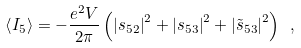<formula> <loc_0><loc_0><loc_500><loc_500>\left \langle I _ { 5 } \right \rangle = - \frac { e ^ { 2 } V } { 2 \pi } \left ( \left | s _ { 5 2 } \right | ^ { 2 } + \left | s _ { 5 3 } \right | ^ { 2 } + \left | \tilde { s } _ { 5 3 } \right | ^ { 2 } \right ) \ ,</formula> 